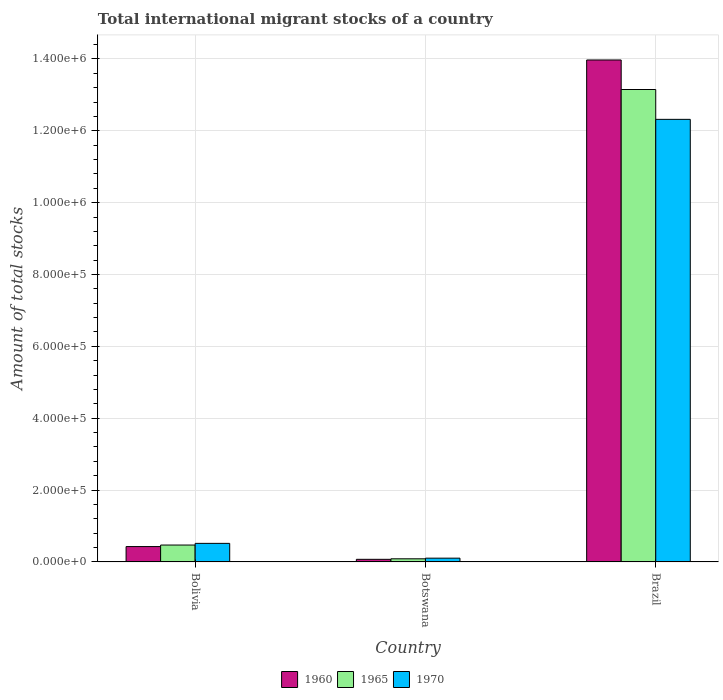How many groups of bars are there?
Make the answer very short. 3. How many bars are there on the 3rd tick from the left?
Offer a very short reply. 3. How many bars are there on the 2nd tick from the right?
Provide a short and direct response. 3. What is the label of the 3rd group of bars from the left?
Your response must be concise. Brazil. What is the amount of total stocks in in 1965 in Brazil?
Your response must be concise. 1.31e+06. Across all countries, what is the maximum amount of total stocks in in 1970?
Offer a very short reply. 1.23e+06. Across all countries, what is the minimum amount of total stocks in in 1965?
Give a very brief answer. 8655. In which country was the amount of total stocks in in 1965 minimum?
Your answer should be compact. Botswana. What is the total amount of total stocks in in 1960 in the graph?
Keep it short and to the point. 1.45e+06. What is the difference between the amount of total stocks in in 1960 in Bolivia and that in Botswana?
Offer a very short reply. 3.55e+04. What is the difference between the amount of total stocks in in 1960 in Botswana and the amount of total stocks in in 1965 in Brazil?
Make the answer very short. -1.31e+06. What is the average amount of total stocks in in 1965 per country?
Offer a very short reply. 4.57e+05. What is the difference between the amount of total stocks in of/in 1965 and amount of total stocks in of/in 1960 in Bolivia?
Provide a short and direct response. 4235. What is the ratio of the amount of total stocks in in 1970 in Bolivia to that in Botswana?
Offer a terse response. 4.96. Is the amount of total stocks in in 1960 in Bolivia less than that in Botswana?
Ensure brevity in your answer.  No. Is the difference between the amount of total stocks in in 1965 in Botswana and Brazil greater than the difference between the amount of total stocks in in 1960 in Botswana and Brazil?
Your response must be concise. Yes. What is the difference between the highest and the second highest amount of total stocks in in 1970?
Offer a terse response. 1.22e+06. What is the difference between the highest and the lowest amount of total stocks in in 1960?
Provide a succinct answer. 1.39e+06. In how many countries, is the amount of total stocks in in 1970 greater than the average amount of total stocks in in 1970 taken over all countries?
Your answer should be very brief. 1. What does the 3rd bar from the right in Bolivia represents?
Offer a terse response. 1960. Are all the bars in the graph horizontal?
Offer a very short reply. No. How many countries are there in the graph?
Offer a terse response. 3. Does the graph contain any zero values?
Your answer should be very brief. No. Does the graph contain grids?
Provide a succinct answer. Yes. What is the title of the graph?
Give a very brief answer. Total international migrant stocks of a country. What is the label or title of the Y-axis?
Ensure brevity in your answer.  Amount of total stocks. What is the Amount of total stocks of 1960 in Bolivia?
Provide a short and direct response. 4.27e+04. What is the Amount of total stocks in 1965 in Bolivia?
Provide a succinct answer. 4.69e+04. What is the Amount of total stocks of 1970 in Bolivia?
Keep it short and to the point. 5.16e+04. What is the Amount of total stocks in 1960 in Botswana?
Provide a short and direct response. 7199. What is the Amount of total stocks of 1965 in Botswana?
Offer a very short reply. 8655. What is the Amount of total stocks in 1970 in Botswana?
Give a very brief answer. 1.04e+04. What is the Amount of total stocks of 1960 in Brazil?
Make the answer very short. 1.40e+06. What is the Amount of total stocks in 1965 in Brazil?
Make the answer very short. 1.31e+06. What is the Amount of total stocks in 1970 in Brazil?
Ensure brevity in your answer.  1.23e+06. Across all countries, what is the maximum Amount of total stocks in 1960?
Provide a short and direct response. 1.40e+06. Across all countries, what is the maximum Amount of total stocks of 1965?
Provide a short and direct response. 1.31e+06. Across all countries, what is the maximum Amount of total stocks of 1970?
Offer a terse response. 1.23e+06. Across all countries, what is the minimum Amount of total stocks of 1960?
Your response must be concise. 7199. Across all countries, what is the minimum Amount of total stocks of 1965?
Keep it short and to the point. 8655. Across all countries, what is the minimum Amount of total stocks in 1970?
Provide a succinct answer. 1.04e+04. What is the total Amount of total stocks in 1960 in the graph?
Provide a succinct answer. 1.45e+06. What is the total Amount of total stocks of 1965 in the graph?
Your answer should be compact. 1.37e+06. What is the total Amount of total stocks of 1970 in the graph?
Your answer should be very brief. 1.29e+06. What is the difference between the Amount of total stocks in 1960 in Bolivia and that in Botswana?
Provide a succinct answer. 3.55e+04. What is the difference between the Amount of total stocks of 1965 in Bolivia and that in Botswana?
Keep it short and to the point. 3.83e+04. What is the difference between the Amount of total stocks of 1970 in Bolivia and that in Botswana?
Make the answer very short. 4.12e+04. What is the difference between the Amount of total stocks of 1960 in Bolivia and that in Brazil?
Make the answer very short. -1.35e+06. What is the difference between the Amount of total stocks of 1965 in Bolivia and that in Brazil?
Your response must be concise. -1.27e+06. What is the difference between the Amount of total stocks of 1970 in Bolivia and that in Brazil?
Your answer should be compact. -1.18e+06. What is the difference between the Amount of total stocks of 1960 in Botswana and that in Brazil?
Your response must be concise. -1.39e+06. What is the difference between the Amount of total stocks of 1965 in Botswana and that in Brazil?
Offer a terse response. -1.31e+06. What is the difference between the Amount of total stocks of 1970 in Botswana and that in Brazil?
Provide a succinct answer. -1.22e+06. What is the difference between the Amount of total stocks of 1960 in Bolivia and the Amount of total stocks of 1965 in Botswana?
Provide a succinct answer. 3.41e+04. What is the difference between the Amount of total stocks in 1960 in Bolivia and the Amount of total stocks in 1970 in Botswana?
Your answer should be very brief. 3.23e+04. What is the difference between the Amount of total stocks in 1965 in Bolivia and the Amount of total stocks in 1970 in Botswana?
Offer a terse response. 3.65e+04. What is the difference between the Amount of total stocks in 1960 in Bolivia and the Amount of total stocks in 1965 in Brazil?
Make the answer very short. -1.27e+06. What is the difference between the Amount of total stocks of 1960 in Bolivia and the Amount of total stocks of 1970 in Brazil?
Provide a short and direct response. -1.19e+06. What is the difference between the Amount of total stocks in 1965 in Bolivia and the Amount of total stocks in 1970 in Brazil?
Your answer should be compact. -1.18e+06. What is the difference between the Amount of total stocks in 1960 in Botswana and the Amount of total stocks in 1965 in Brazil?
Offer a terse response. -1.31e+06. What is the difference between the Amount of total stocks in 1960 in Botswana and the Amount of total stocks in 1970 in Brazil?
Your answer should be very brief. -1.22e+06. What is the difference between the Amount of total stocks of 1965 in Botswana and the Amount of total stocks of 1970 in Brazil?
Your response must be concise. -1.22e+06. What is the average Amount of total stocks in 1960 per country?
Your response must be concise. 4.82e+05. What is the average Amount of total stocks of 1965 per country?
Your answer should be very brief. 4.57e+05. What is the average Amount of total stocks of 1970 per country?
Keep it short and to the point. 4.31e+05. What is the difference between the Amount of total stocks of 1960 and Amount of total stocks of 1965 in Bolivia?
Your answer should be very brief. -4235. What is the difference between the Amount of total stocks in 1960 and Amount of total stocks in 1970 in Bolivia?
Make the answer very short. -8890. What is the difference between the Amount of total stocks in 1965 and Amount of total stocks in 1970 in Bolivia?
Provide a succinct answer. -4655. What is the difference between the Amount of total stocks in 1960 and Amount of total stocks in 1965 in Botswana?
Make the answer very short. -1456. What is the difference between the Amount of total stocks of 1960 and Amount of total stocks of 1970 in Botswana?
Offer a terse response. -3205. What is the difference between the Amount of total stocks in 1965 and Amount of total stocks in 1970 in Botswana?
Give a very brief answer. -1749. What is the difference between the Amount of total stocks in 1960 and Amount of total stocks in 1965 in Brazil?
Your answer should be compact. 8.22e+04. What is the difference between the Amount of total stocks of 1960 and Amount of total stocks of 1970 in Brazil?
Offer a terse response. 1.65e+05. What is the difference between the Amount of total stocks in 1965 and Amount of total stocks in 1970 in Brazil?
Offer a very short reply. 8.31e+04. What is the ratio of the Amount of total stocks of 1960 in Bolivia to that in Botswana?
Ensure brevity in your answer.  5.93. What is the ratio of the Amount of total stocks in 1965 in Bolivia to that in Botswana?
Offer a terse response. 5.42. What is the ratio of the Amount of total stocks of 1970 in Bolivia to that in Botswana?
Give a very brief answer. 4.96. What is the ratio of the Amount of total stocks of 1960 in Bolivia to that in Brazil?
Provide a succinct answer. 0.03. What is the ratio of the Amount of total stocks in 1965 in Bolivia to that in Brazil?
Your answer should be very brief. 0.04. What is the ratio of the Amount of total stocks in 1970 in Bolivia to that in Brazil?
Offer a very short reply. 0.04. What is the ratio of the Amount of total stocks in 1960 in Botswana to that in Brazil?
Your answer should be very brief. 0.01. What is the ratio of the Amount of total stocks in 1965 in Botswana to that in Brazil?
Offer a very short reply. 0.01. What is the ratio of the Amount of total stocks of 1970 in Botswana to that in Brazil?
Your answer should be compact. 0.01. What is the difference between the highest and the second highest Amount of total stocks in 1960?
Your answer should be very brief. 1.35e+06. What is the difference between the highest and the second highest Amount of total stocks in 1965?
Offer a very short reply. 1.27e+06. What is the difference between the highest and the second highest Amount of total stocks in 1970?
Keep it short and to the point. 1.18e+06. What is the difference between the highest and the lowest Amount of total stocks of 1960?
Offer a very short reply. 1.39e+06. What is the difference between the highest and the lowest Amount of total stocks in 1965?
Provide a short and direct response. 1.31e+06. What is the difference between the highest and the lowest Amount of total stocks of 1970?
Your response must be concise. 1.22e+06. 